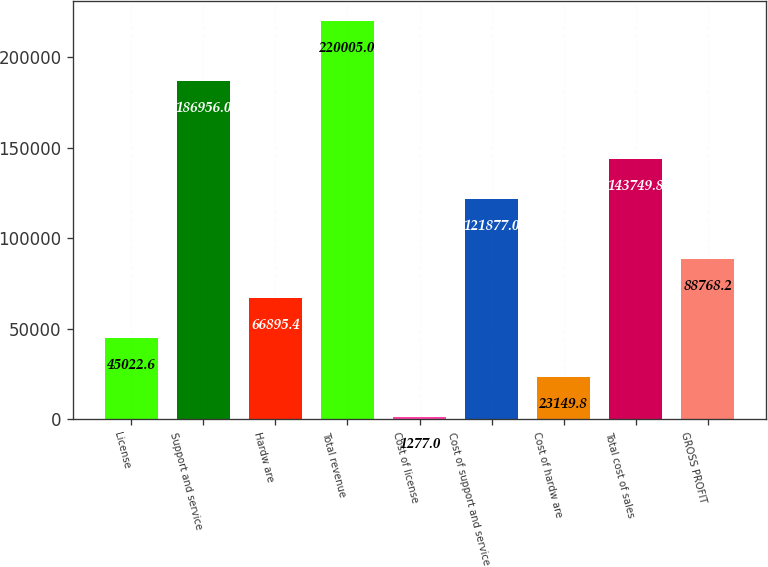Convert chart. <chart><loc_0><loc_0><loc_500><loc_500><bar_chart><fcel>License<fcel>Support and service<fcel>Hardw are<fcel>Total revenue<fcel>Cost of license<fcel>Cost of support and service<fcel>Cost of hardw are<fcel>Total cost of sales<fcel>GROSS PROFIT<nl><fcel>45022.6<fcel>186956<fcel>66895.4<fcel>220005<fcel>1277<fcel>121877<fcel>23149.8<fcel>143750<fcel>88768.2<nl></chart> 